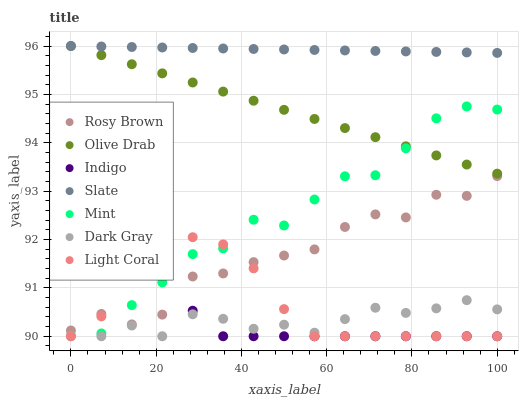Does Dark Gray have the minimum area under the curve?
Answer yes or no. Yes. Does Slate have the maximum area under the curve?
Answer yes or no. Yes. Does Indigo have the minimum area under the curve?
Answer yes or no. No. Does Indigo have the maximum area under the curve?
Answer yes or no. No. Is Slate the smoothest?
Answer yes or no. Yes. Is Rosy Brown the roughest?
Answer yes or no. Yes. Is Indigo the smoothest?
Answer yes or no. No. Is Indigo the roughest?
Answer yes or no. No. Does Light Coral have the lowest value?
Answer yes or no. Yes. Does Slate have the lowest value?
Answer yes or no. No. Does Olive Drab have the highest value?
Answer yes or no. Yes. Does Indigo have the highest value?
Answer yes or no. No. Is Rosy Brown less than Olive Drab?
Answer yes or no. Yes. Is Olive Drab greater than Dark Gray?
Answer yes or no. Yes. Does Light Coral intersect Mint?
Answer yes or no. Yes. Is Light Coral less than Mint?
Answer yes or no. No. Is Light Coral greater than Mint?
Answer yes or no. No. Does Rosy Brown intersect Olive Drab?
Answer yes or no. No. 